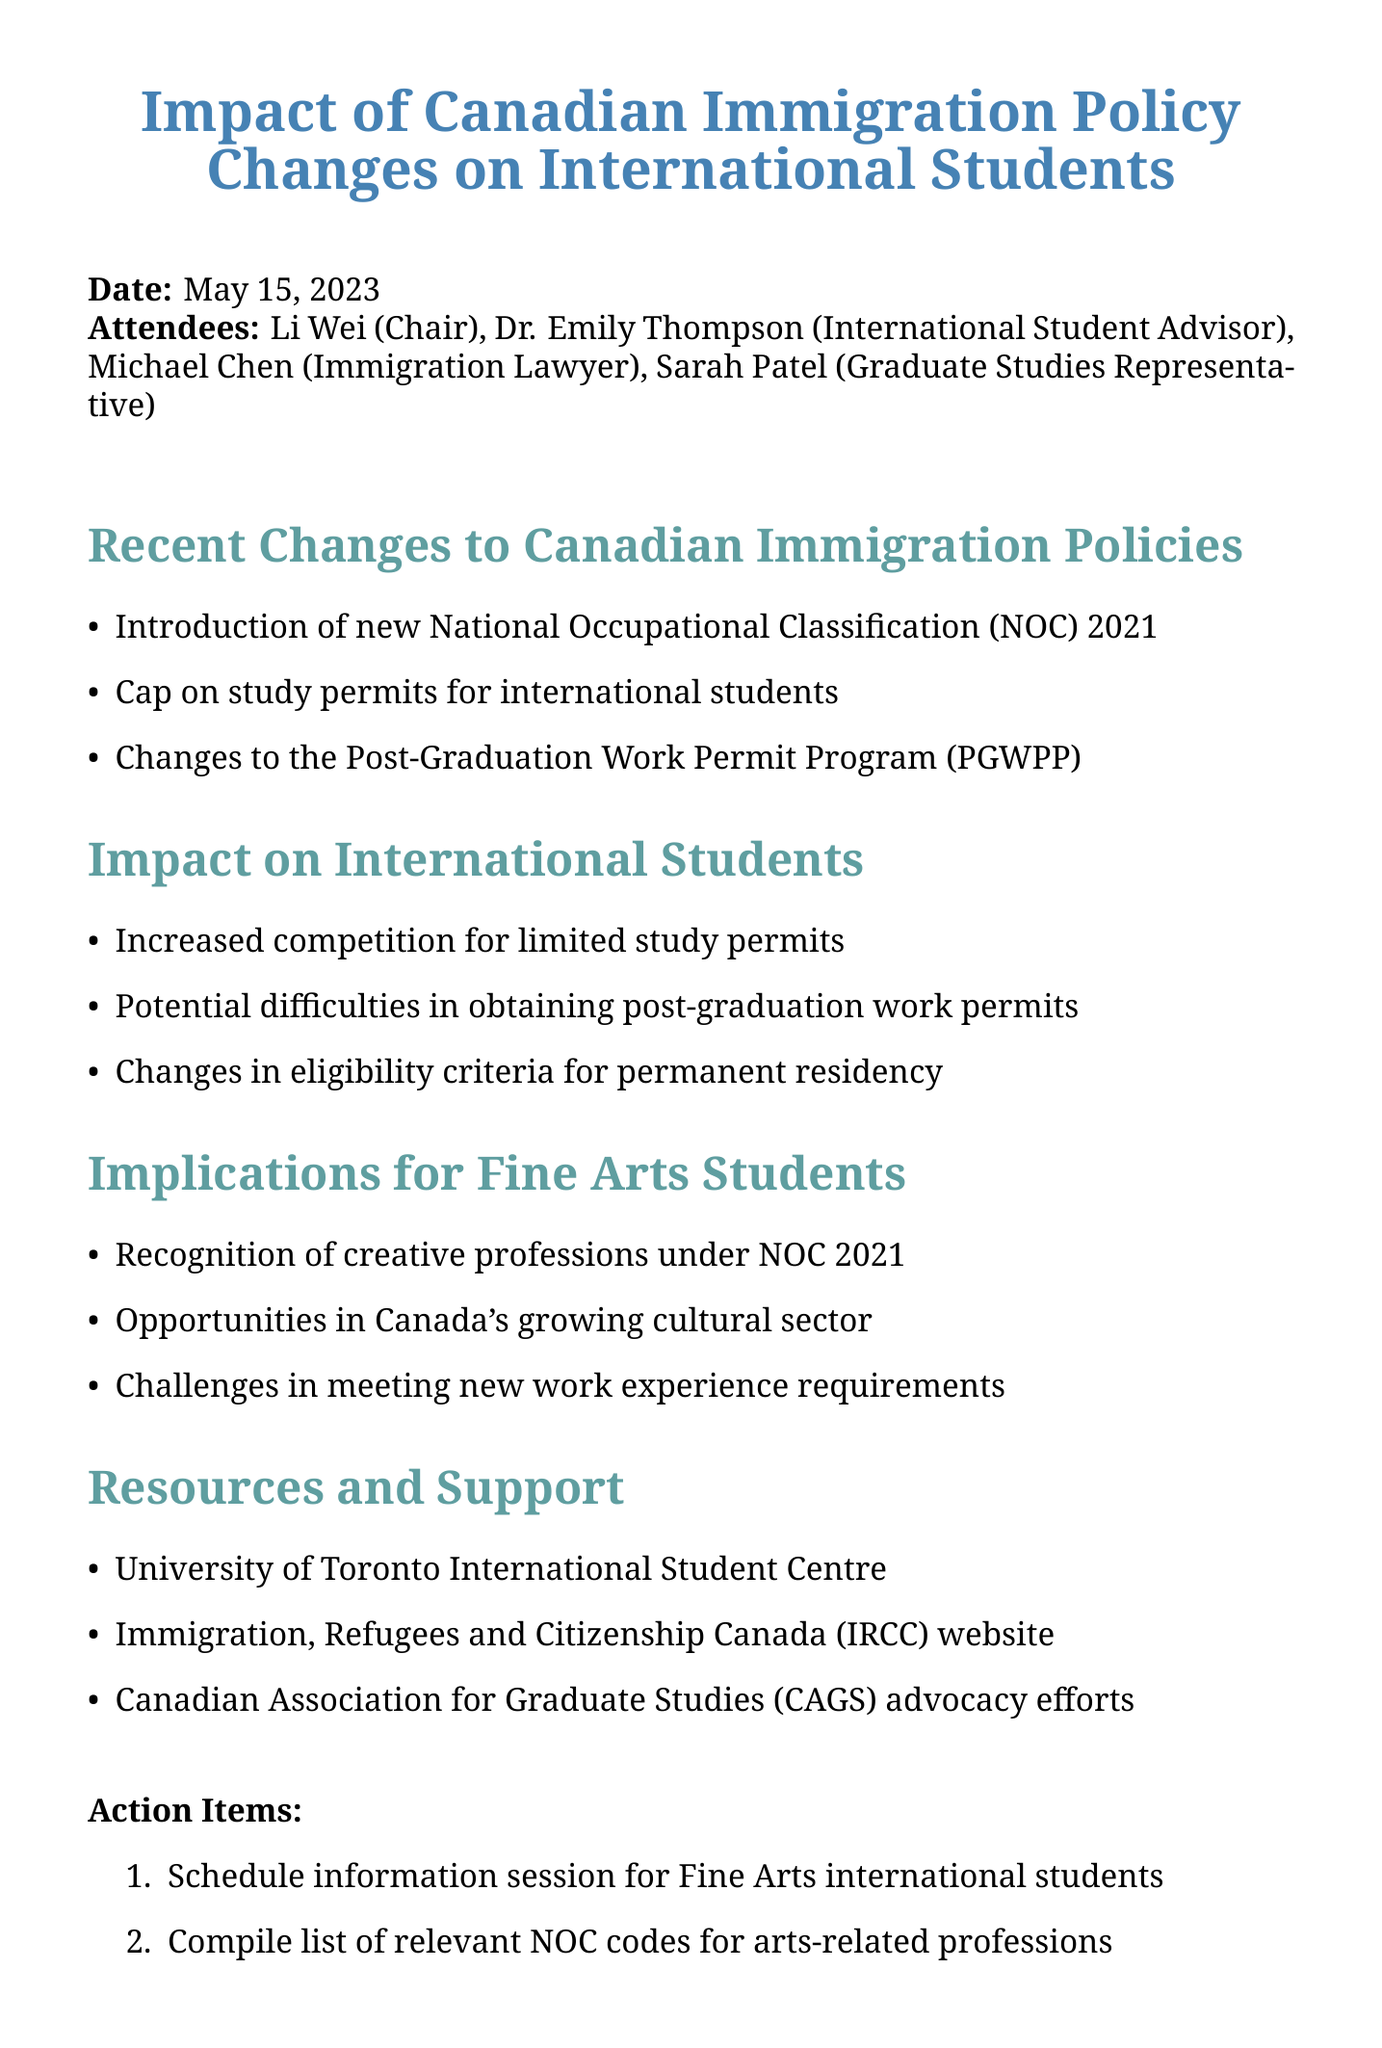What is the meeting title? The meeting title is explicitly stated at the beginning of the document.
Answer: Impact of Canadian Immigration Policy Changes on International Students Who chaired the meeting? The person who chaired the meeting is listed among the attendees.
Answer: Li Wei What is the date of the next meeting? The next meeting date is mentioned towards the end of the document.
Answer: June 15, 2023 What significant change was introduced in the immigration policies? The specific point related to immigration policies is listed under recent changes.
Answer: New National Occupational Classification (NOC) 2021 What are the implications for Fine Arts students? The implications for Fine Arts students are detailed in a specific section of the document.
Answer: Recognition of creative professions under NOC 2021 What did the attendees discuss regarding post-graduation work permits? This topic is reflected in the points under the "Impact on International Students" section.
Answer: Potential difficulties in obtaining post-graduation work permits What action item was proposed related to Fine Arts international students? Proposed actions are listed towards the end of the document.
Answer: Schedule information session for Fine Arts international students Which organization is mentioned as a resource for international students? The resource organizations are listed in the resources and support section.
Answer: University of Toronto International Student Centre How many attendees were present at the meeting? The number of attendees can be counted from the list provided.
Answer: Four 